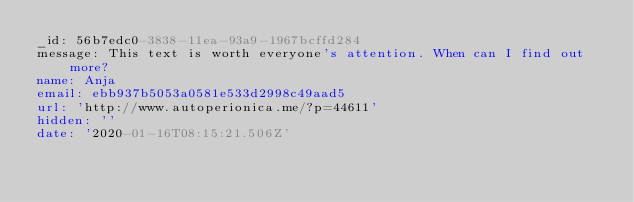<code> <loc_0><loc_0><loc_500><loc_500><_YAML_>_id: 56b7edc0-3838-11ea-93a9-1967bcffd284
message: This text is worth everyone's attention. When can I find out more?
name: Anja
email: ebb937b5053a0581e533d2998c49aad5
url: 'http://www.autoperionica.me/?p=44611'
hidden: ''
date: '2020-01-16T08:15:21.506Z'
</code> 